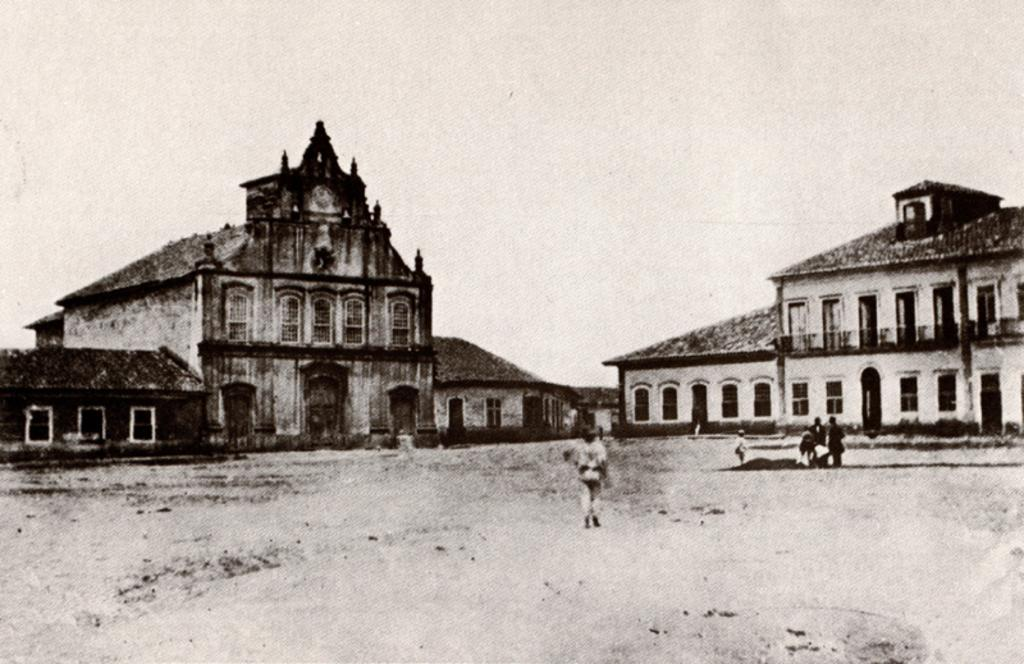What is the color scheme of the image? The image is black and white. What is the main subject of the image? There is a person walking in the middle of the image. What type of structures can be seen in the image? There are buildings in the image. What is the weather like in the image? The sky is cloudy in the image. How many lizards are crawling on the canvas in the image? There are no lizards or canvas present in the image. What type of slave is depicted in the image? There is no depiction of a slave in the image; it features a person walking and buildings. 